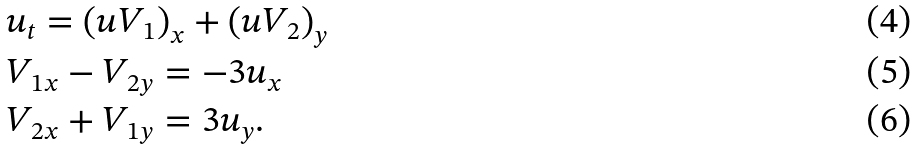Convert formula to latex. <formula><loc_0><loc_0><loc_500><loc_500>& u _ { t } = \left ( u V _ { 1 } \right ) _ { x } + \left ( u V _ { 2 } \right ) _ { y } \\ & V _ { 1 x } - V _ { 2 y } = - 3 u _ { x } \\ & V _ { 2 x } + V _ { 1 y } = 3 u _ { y } .</formula> 